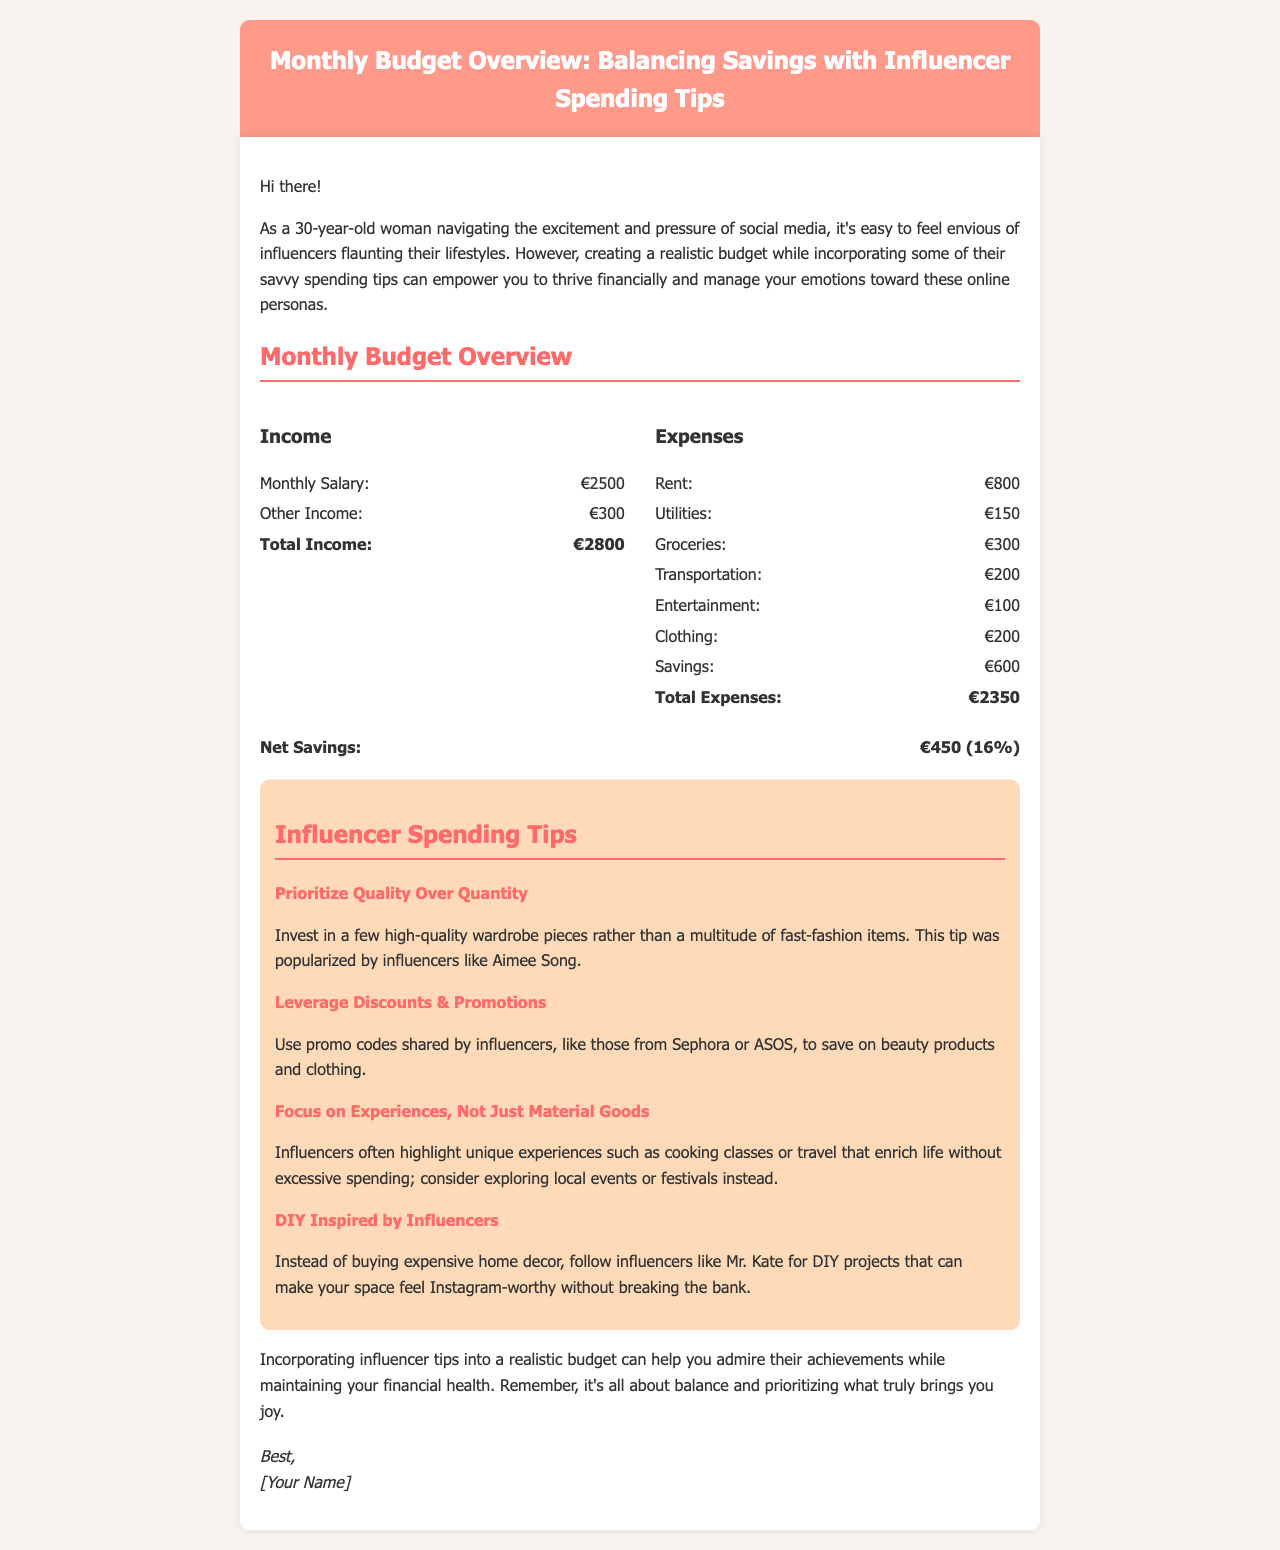What is the total income? The total income is calculated by adding the monthly salary and other income, which is €2500 + €300 = €2800.
Answer: €2800 What is the total expenses? The total expenses are the sum of all categorized expenses, which adds up to €2350.
Answer: €2350 How much is allocated for savings? The budget explicitly states that €600 is allocated for savings.
Answer: €600 What percentage of the income does the net savings represent? The document states the net savings amount is €450, which is indicated as 16% of the total income.
Answer: 16% Which influencer tip suggests avoiding fast-fashion items? The tip encourages prioritizing quality over quantity, as popularized by Aimee Song.
Answer: Prioritize Quality Over Quantity What types of experiences does the influencer tip recommend? The tip focuses on unique experiences such as cooking classes or travel instead of material goods.
Answer: Experiences What should you follow instead of buying expensive home decor? Following influencers like Mr. Kate for DIY projects is recommended.
Answer: DIY Inspired by Influencers What is the essence of the concluding message? The conclusion emphasizes achieving balance while admiring influencers' achievements within a realistic budget.
Answer: Balance 